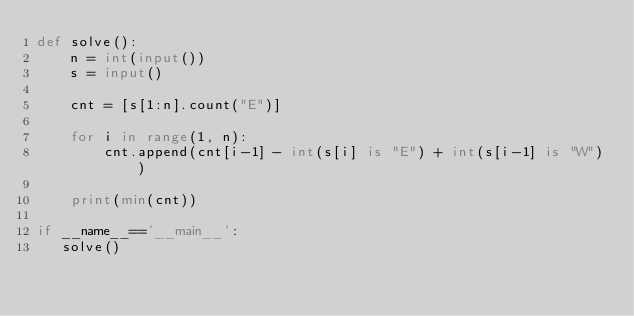Convert code to text. <code><loc_0><loc_0><loc_500><loc_500><_Python_>def solve():
    n = int(input())
    s = input()

    cnt = [s[1:n].count("E")]

    for i in range(1, n):
        cnt.append(cnt[i-1] - int(s[i] is "E") + int(s[i-1] is "W"))

    print(min(cnt))

if __name__=='__main__':
   solve()</code> 